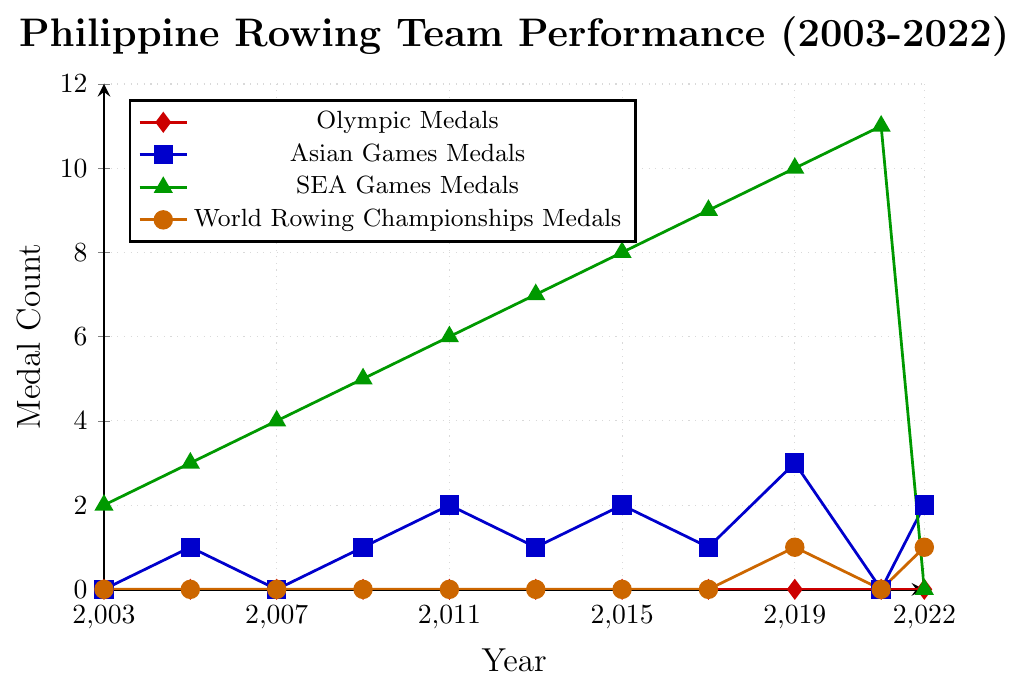What is the trend of SEA Games Medals from 2003 to 2021? To identify the trend, observe the green line representing SEA Games Medals. The medal count gradually increases each year from 2 in 2003 to 11 in 2021.
Answer: Increasing trend How many medals did the Philippine rowing team win in total in Asian Games and SEA Games in 2019? To find the total, add the medals from Asian Games (blue line) and SEA Games (green line) in 2019. Asian Games: 3 medals, SEA Games: 10 medals. Total = 3 + 10 = 13
Answer: 13 Which year saw the highest number of World Rowing Championships Medals? To find the year with the highest World Rowing Championships Medals, look for the peak in the orange line. The highest point occurs in 2019 and 2022 with 1 medal each.
Answer: 2019 and 2022 Did the Philippine rowing team ever win any Olympic Medals from 2003 to 2022? The red line represents Olympic Medals, which remains at zero throughout the period from 2003 to 2022.
Answer: No Which type of medals shows the most significant increase over the years? To determine the most significant increase, compare the slopes of the lines. The SEA Games Medals (green line) shows the most substantial increment, growing from 2 in 2003 to 11 in 2021.
Answer: SEA Games Medals In which year did the Philippine rowing team win the most medals overall at international competitions? To find the year with the most overall medals, sum the medals for each year and compare. The sums for SEA Games, Asian Games, and World Championships in 2019 are: SEA Games: 10, Asian Games: 3, World Championships: 1. Total = 10 + 3 + 1 = 14, which is the highest.
Answer: 2019 How many times did the Philippine rowing team win exactly 1 medal in the Asian Games between 2003 and 2022? Check the blue line for points where the count is exactly 1. These occur in 2005, 2013, and 2017.
Answer: 3 times What was the total medal count for the Philippine rowing team in 2022, and how did it compare to 2021? Calculate the total medals for each year: For 2021, SEA Games: 11, Total = 11. For 2022, Asian Games: 2, World Championships: 1, Total = 2 + 1 = 3. Comparison: 2021 had more medals than 2022.
Answer: 2022: 3, 2021: 11; 2021 had more What is the difference in medal count between the years with the highest and lowest SEA Games Medals? The highest SEA Games Medals were in 2021 with 11 medals, and the lowest was in 2003 with 2 medals. Difference = 11 - 2 = 9
Answer: 9 How many years did the Philippine rowing team not win any medals in the World Rowing Championships? Check the orange line for years with zero medals. The years are: 2003, 2005, 2007, 2009, 2011, 2013, 2015, 2017, and 2021.
Answer: 9 years 